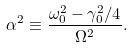Convert formula to latex. <formula><loc_0><loc_0><loc_500><loc_500>\alpha ^ { 2 } \equiv \frac { \omega _ { 0 } ^ { 2 } - \gamma _ { 0 } ^ { 2 } / 4 } { \Omega ^ { 2 } } .</formula> 